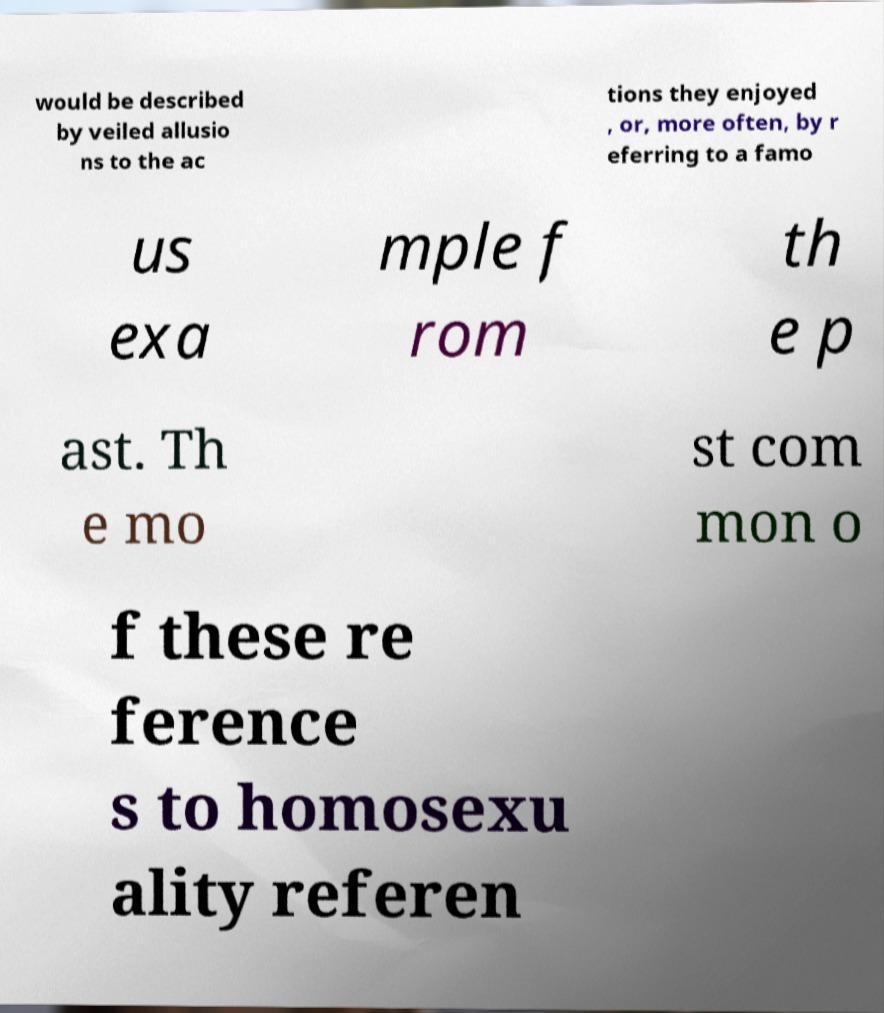Could you assist in decoding the text presented in this image and type it out clearly? would be described by veiled allusio ns to the ac tions they enjoyed , or, more often, by r eferring to a famo us exa mple f rom th e p ast. Th e mo st com mon o f these re ference s to homosexu ality referen 